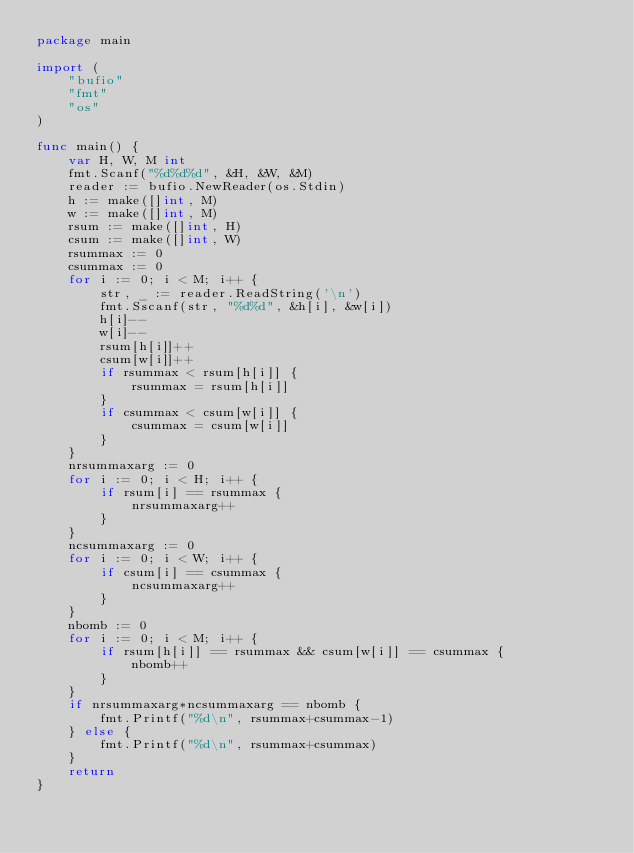Convert code to text. <code><loc_0><loc_0><loc_500><loc_500><_Go_>package main

import (
	"bufio"
	"fmt"
	"os"
)

func main() {
	var H, W, M int
	fmt.Scanf("%d%d%d", &H, &W, &M)
	reader := bufio.NewReader(os.Stdin)
	h := make([]int, M)
	w := make([]int, M)
	rsum := make([]int, H)
	csum := make([]int, W)
	rsummax := 0
	csummax := 0
	for i := 0; i < M; i++ {
		str, _ := reader.ReadString('\n')
		fmt.Sscanf(str, "%d%d", &h[i], &w[i])
		h[i]--
		w[i]--
		rsum[h[i]]++
		csum[w[i]]++
		if rsummax < rsum[h[i]] {
			rsummax = rsum[h[i]]
		}
		if csummax < csum[w[i]] {
			csummax = csum[w[i]]
		}
	}
	nrsummaxarg := 0
	for i := 0; i < H; i++ {
		if rsum[i] == rsummax {
			nrsummaxarg++
		}
	}
	ncsummaxarg := 0
	for i := 0; i < W; i++ {
		if csum[i] == csummax {
			ncsummaxarg++
		}
	}
	nbomb := 0
	for i := 0; i < M; i++ {
		if rsum[h[i]] == rsummax && csum[w[i]] == csummax {
			nbomb++
		}
	}
	if nrsummaxarg*ncsummaxarg == nbomb {
		fmt.Printf("%d\n", rsummax+csummax-1)
	} else {
		fmt.Printf("%d\n", rsummax+csummax)
	}
	return
}
</code> 